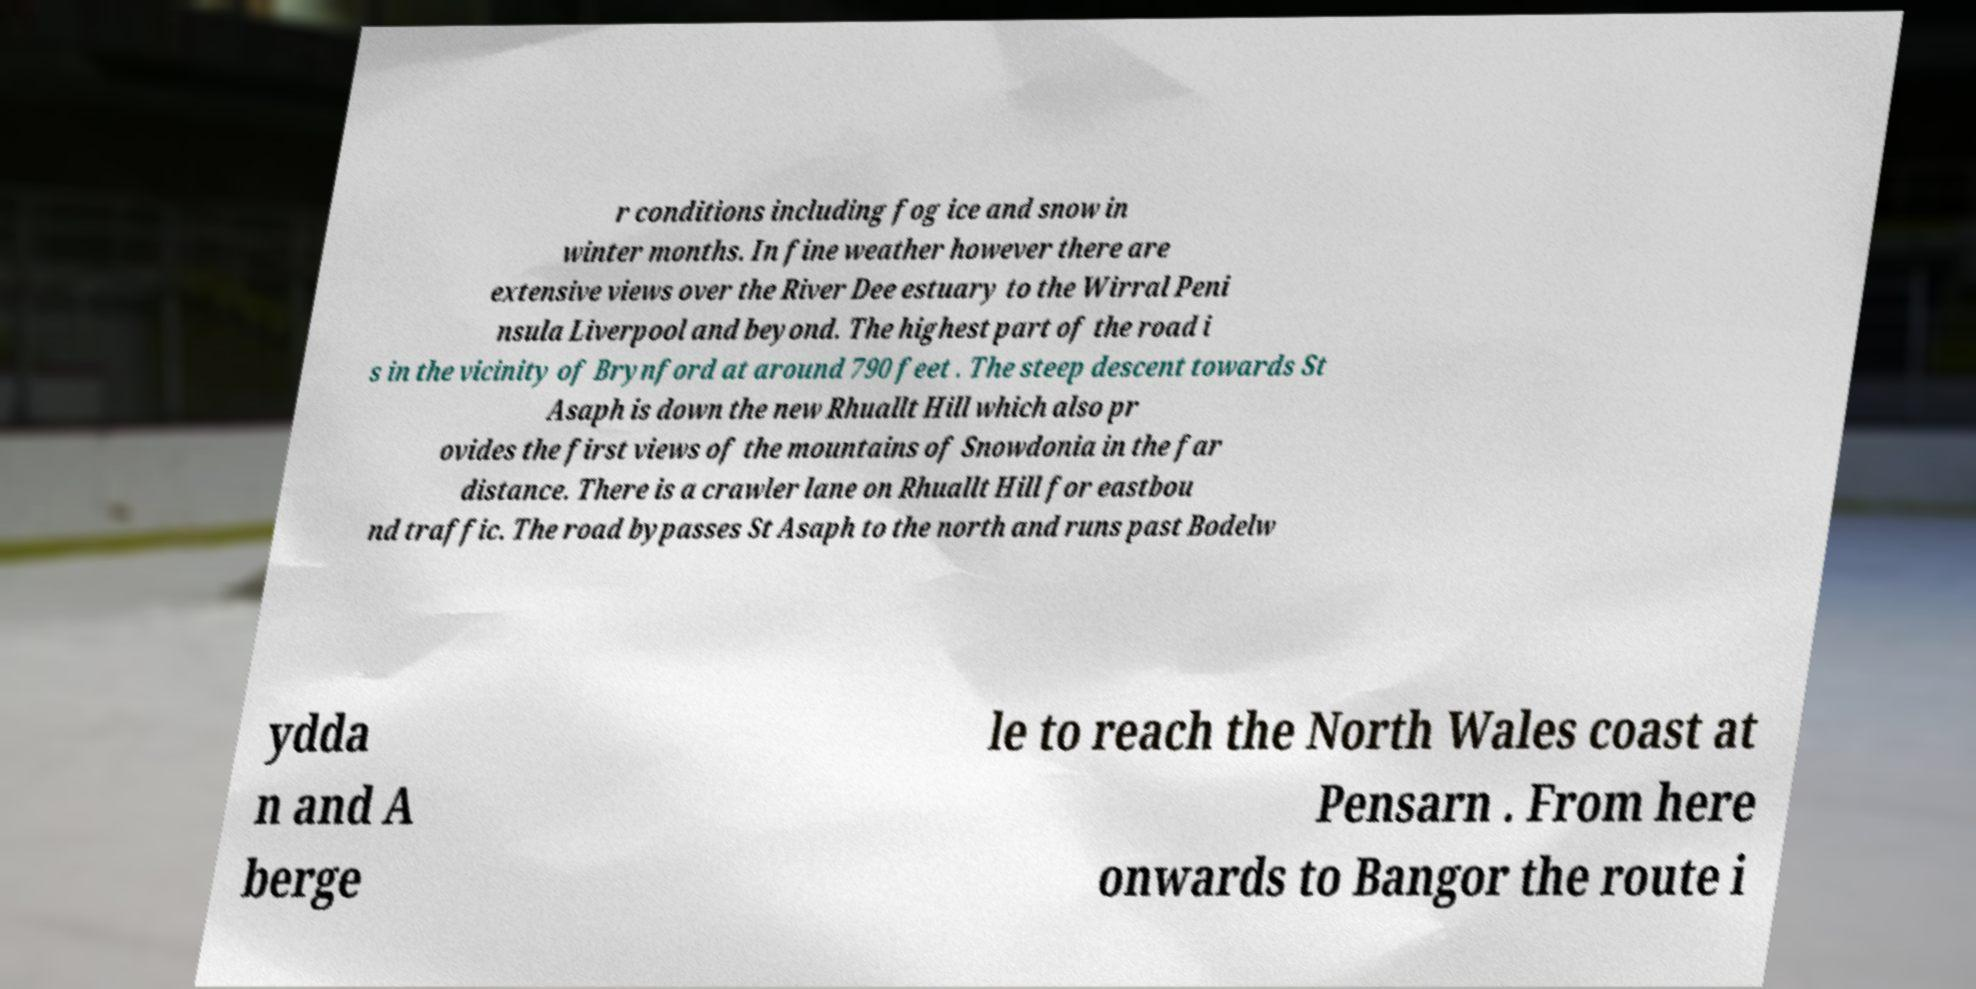Can you read and provide the text displayed in the image?This photo seems to have some interesting text. Can you extract and type it out for me? r conditions including fog ice and snow in winter months. In fine weather however there are extensive views over the River Dee estuary to the Wirral Peni nsula Liverpool and beyond. The highest part of the road i s in the vicinity of Brynford at around 790 feet . The steep descent towards St Asaph is down the new Rhuallt Hill which also pr ovides the first views of the mountains of Snowdonia in the far distance. There is a crawler lane on Rhuallt Hill for eastbou nd traffic. The road bypasses St Asaph to the north and runs past Bodelw ydda n and A berge le to reach the North Wales coast at Pensarn . From here onwards to Bangor the route i 